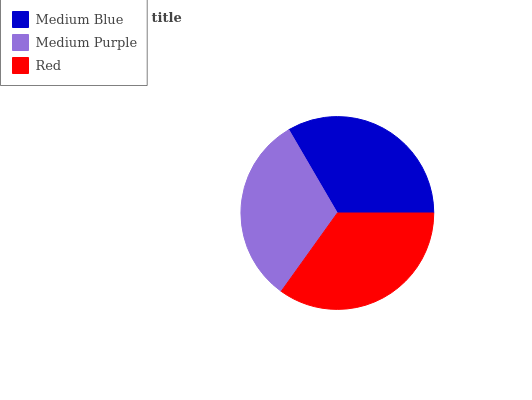Is Medium Purple the minimum?
Answer yes or no. Yes. Is Red the maximum?
Answer yes or no. Yes. Is Red the minimum?
Answer yes or no. No. Is Medium Purple the maximum?
Answer yes or no. No. Is Red greater than Medium Purple?
Answer yes or no. Yes. Is Medium Purple less than Red?
Answer yes or no. Yes. Is Medium Purple greater than Red?
Answer yes or no. No. Is Red less than Medium Purple?
Answer yes or no. No. Is Medium Blue the high median?
Answer yes or no. Yes. Is Medium Blue the low median?
Answer yes or no. Yes. Is Medium Purple the high median?
Answer yes or no. No. Is Red the low median?
Answer yes or no. No. 